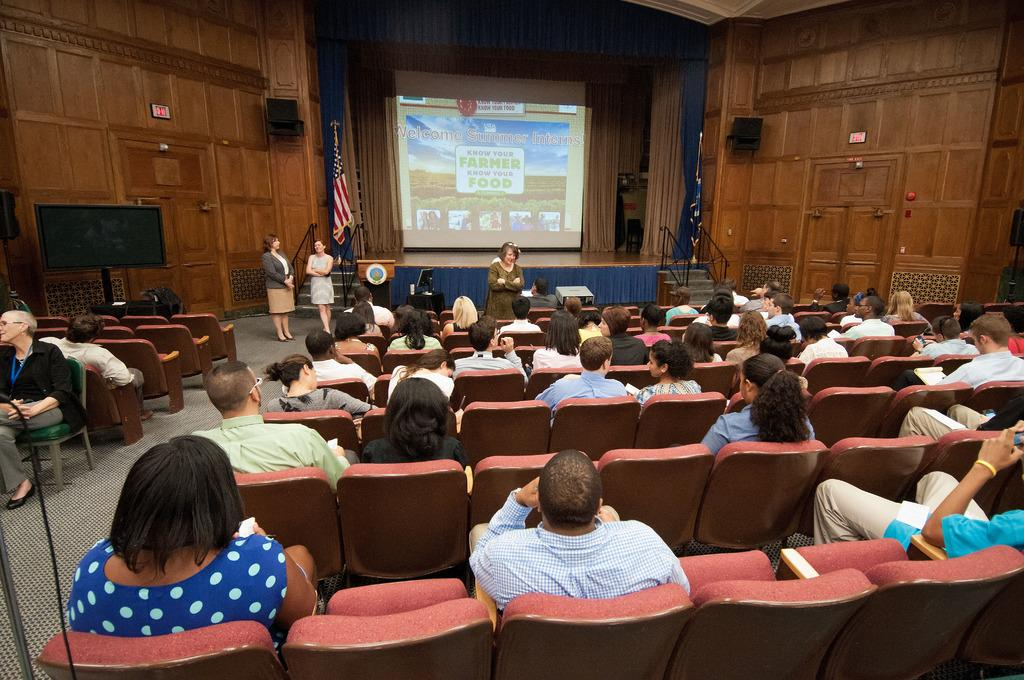What are the people in the image doing? The people in the image are sitting on chairs. What are the people looking at or towards? The people are looking in one direction. Can you describe the individuals standing on the left side of the image? There are 2 women standing on the left side of the image. What is the main feature in the middle of the image? There is a projected screen in the middle of the image. What type of soap is being used to clean the test on the projected screen? There is no soap or test present in the image; it features people sitting on chairs, looking in one direction, and a projected screen in the middle. What color is the sock worn by the person standing on the left side of the image? There is no sock visible on the individuals standing on the left side of the image. 